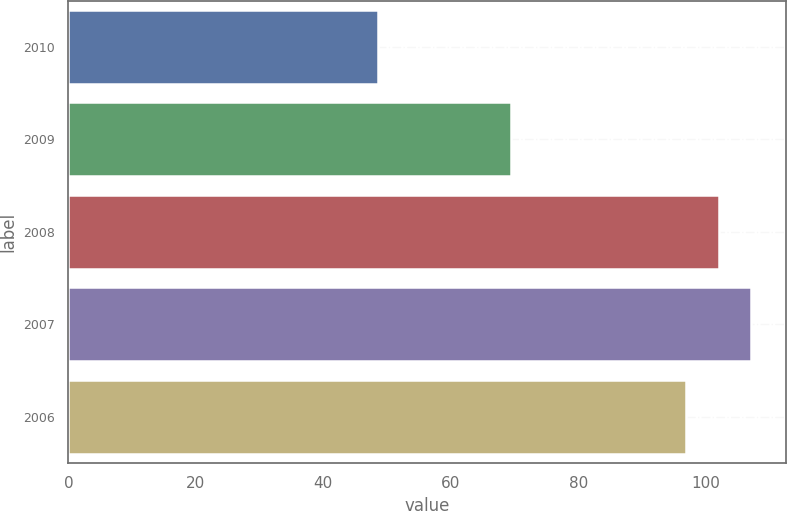Convert chart to OTSL. <chart><loc_0><loc_0><loc_500><loc_500><bar_chart><fcel>2010<fcel>2009<fcel>2008<fcel>2007<fcel>2006<nl><fcel>48.6<fcel>69.4<fcel>102.04<fcel>107.18<fcel>96.9<nl></chart> 